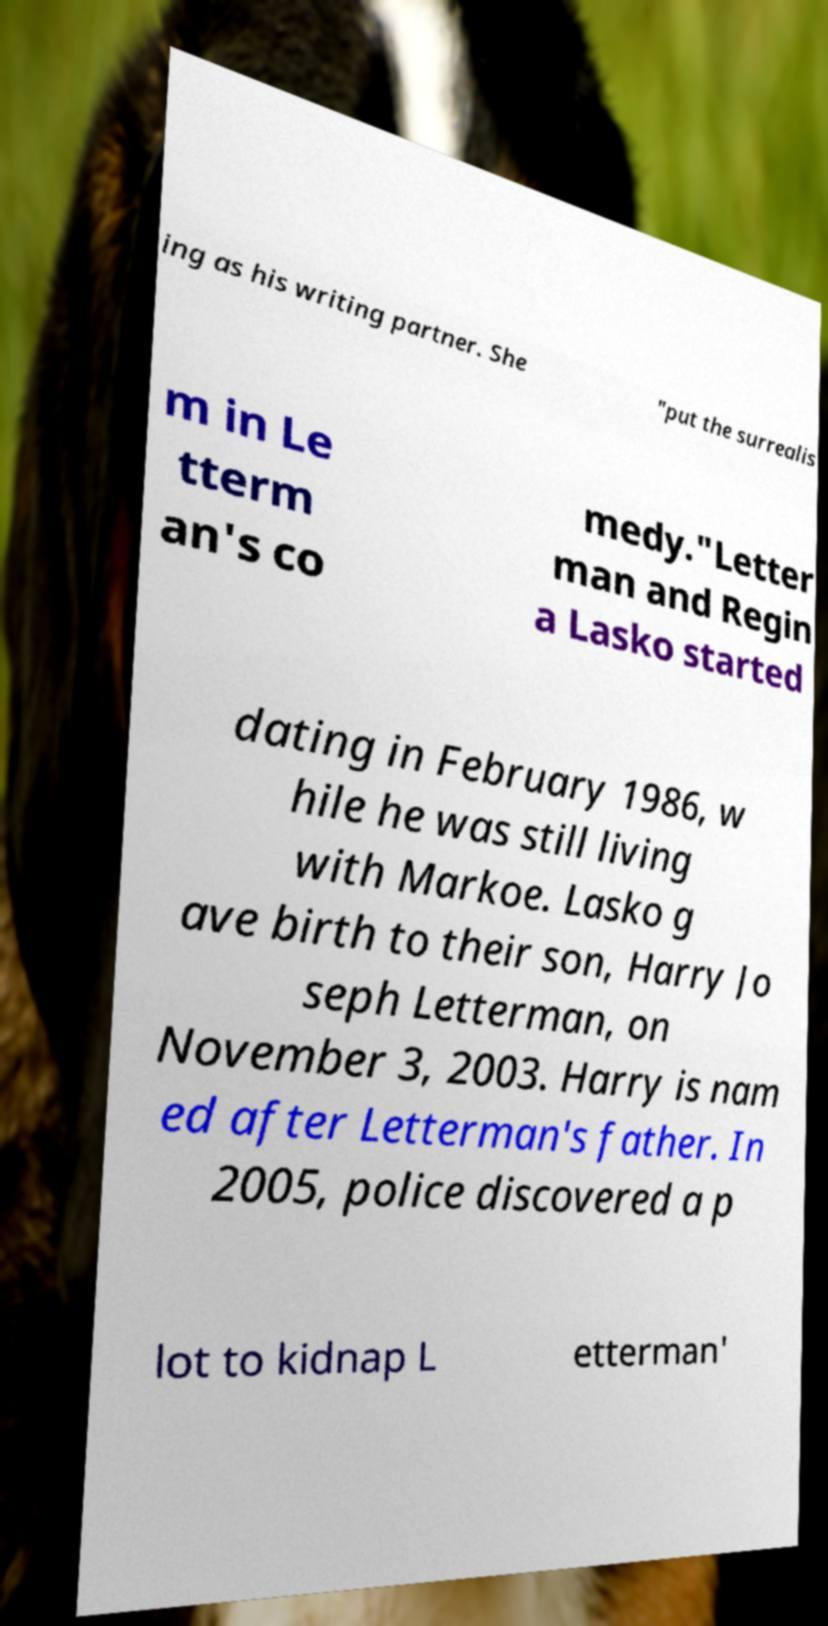What messages or text are displayed in this image? I need them in a readable, typed format. ing as his writing partner. She "put the surrealis m in Le tterm an's co medy."Letter man and Regin a Lasko started dating in February 1986, w hile he was still living with Markoe. Lasko g ave birth to their son, Harry Jo seph Letterman, on November 3, 2003. Harry is nam ed after Letterman's father. In 2005, police discovered a p lot to kidnap L etterman' 